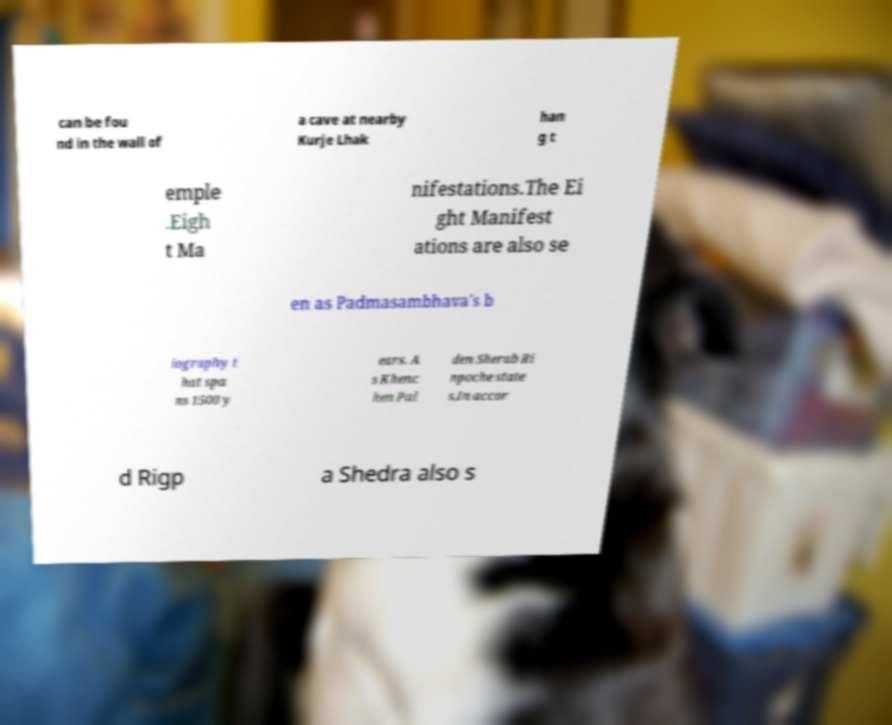I need the written content from this picture converted into text. Can you do that? can be fou nd in the wall of a cave at nearby Kurje Lhak han g t emple .Eigh t Ma nifestations.The Ei ght Manifest ations are also se en as Padmasambhava's b iography t hat spa ns 1500 y ears. A s Khenc hen Pal den Sherab Ri npoche state s,In accor d Rigp a Shedra also s 